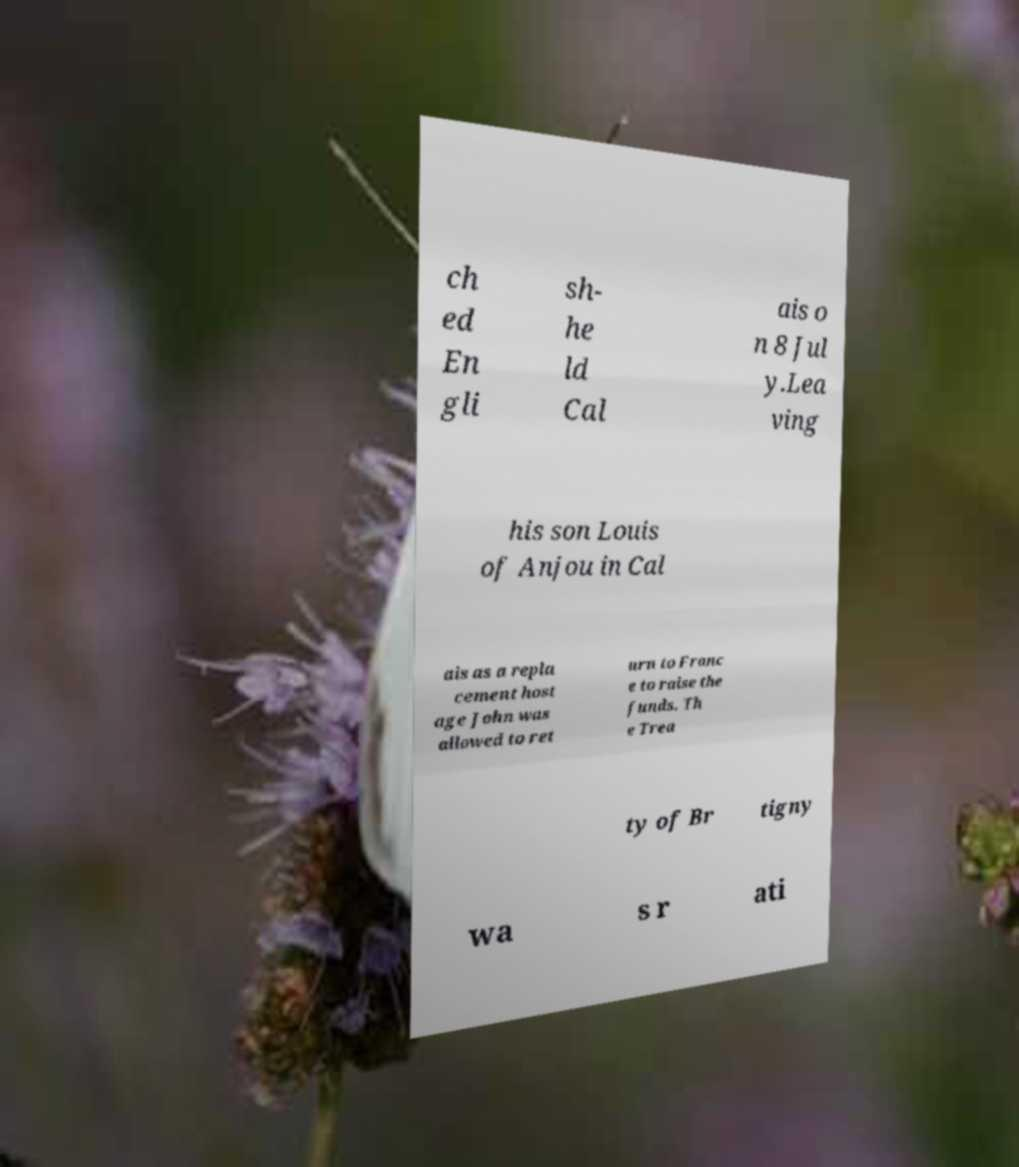For documentation purposes, I need the text within this image transcribed. Could you provide that? ch ed En gli sh- he ld Cal ais o n 8 Jul y.Lea ving his son Louis of Anjou in Cal ais as a repla cement host age John was allowed to ret urn to Franc e to raise the funds. Th e Trea ty of Br tigny wa s r ati 